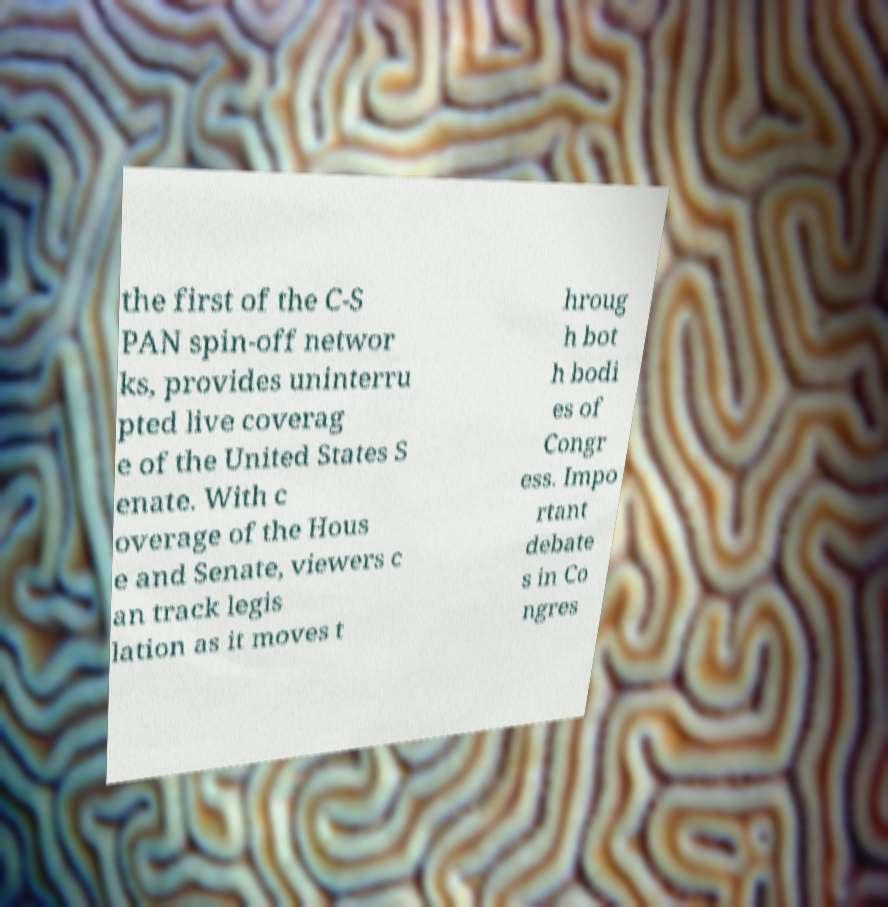What messages or text are displayed in this image? I need them in a readable, typed format. the first of the C-S PAN spin-off networ ks, provides uninterru pted live coverag e of the United States S enate. With c overage of the Hous e and Senate, viewers c an track legis lation as it moves t hroug h bot h bodi es of Congr ess. Impo rtant debate s in Co ngres 